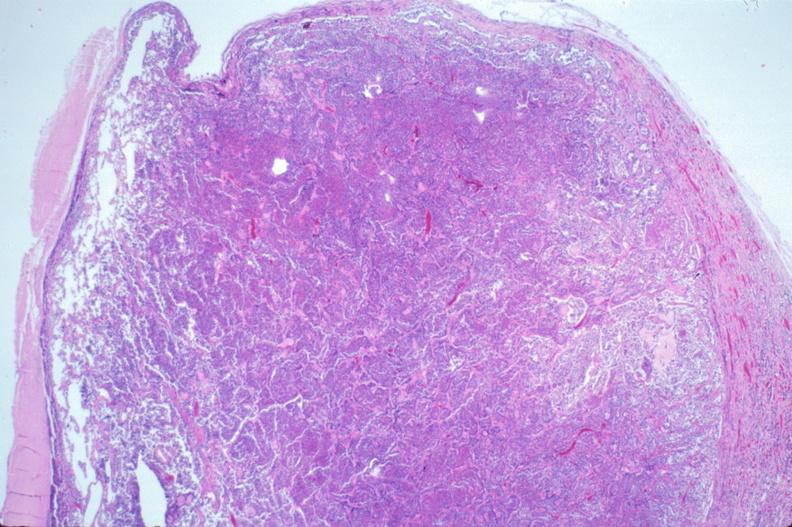what is present?
Answer the question using a single word or phrase. Endocrine 